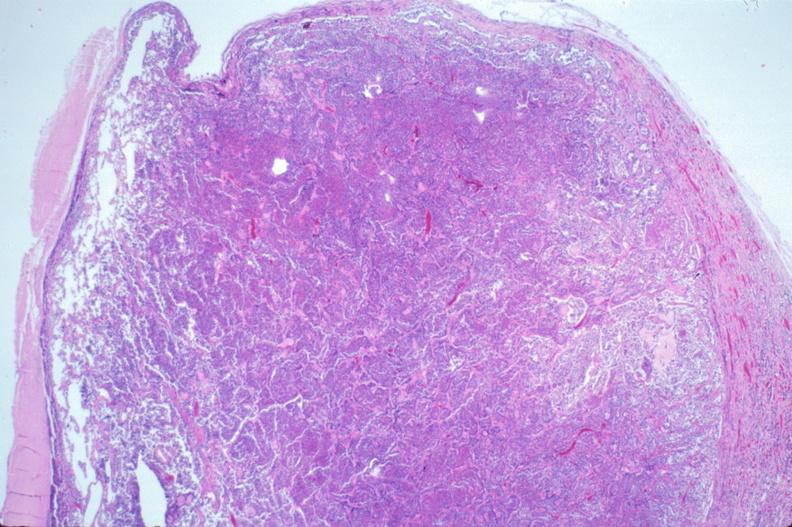what is present?
Answer the question using a single word or phrase. Endocrine 